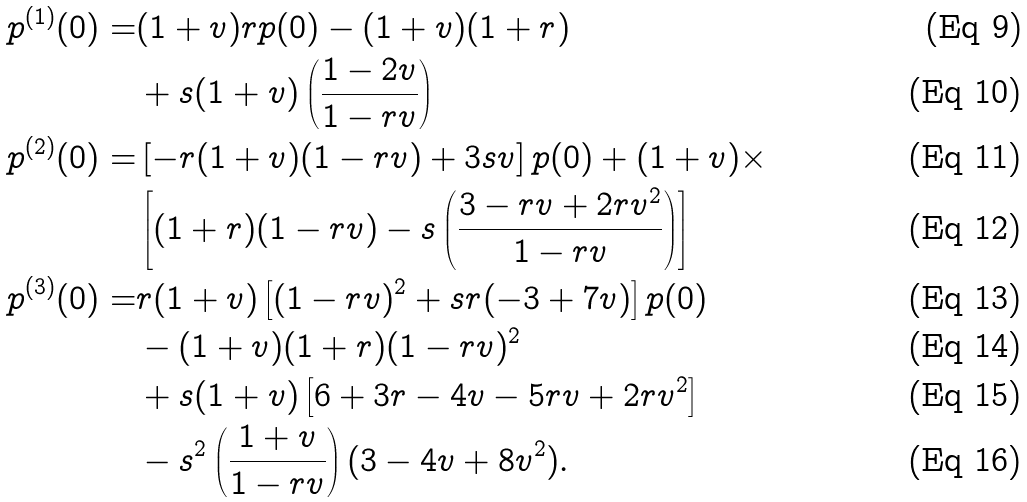<formula> <loc_0><loc_0><loc_500><loc_500>p ^ { ( 1 ) } ( 0 ) = & ( 1 + v ) r p ( 0 ) - ( 1 + v ) ( 1 + r ) \\ & + s ( 1 + v ) \left ( \frac { 1 - 2 v } { 1 - r v } \right ) \\ p ^ { ( 2 ) } ( 0 ) = & \left [ - r ( 1 + v ) ( 1 - r v ) + 3 s v \right ] p ( 0 ) + ( 1 + v ) \times \\ & \left [ ( 1 + r ) ( 1 - r v ) - s \left ( \frac { 3 - r v + 2 r v ^ { 2 } } { 1 - r v } \right ) \right ] \\ p ^ { ( 3 ) } ( 0 ) = & r ( 1 + v ) \left [ ( 1 - r v ) ^ { 2 } + s r ( - 3 + 7 v ) \right ] p ( 0 ) \\ & - ( 1 + v ) ( 1 + r ) ( 1 - r v ) ^ { 2 } \\ & + s ( 1 + v ) \left [ 6 + 3 r - 4 v - 5 r v + 2 r v ^ { 2 } \right ] \\ & - s ^ { 2 } \left ( \frac { 1 + v } { 1 - r v } \right ) ( 3 - 4 v + 8 v ^ { 2 } ) .</formula> 